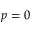Convert formula to latex. <formula><loc_0><loc_0><loc_500><loc_500>p = 0</formula> 